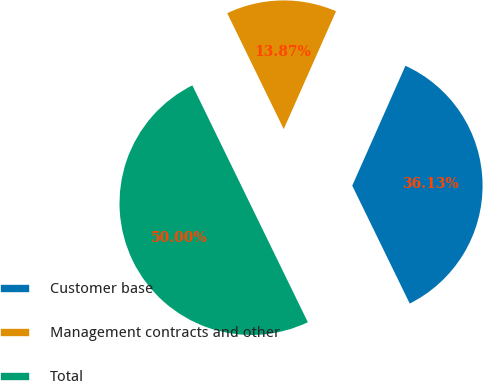<chart> <loc_0><loc_0><loc_500><loc_500><pie_chart><fcel>Customer base<fcel>Management contracts and other<fcel>Total<nl><fcel>36.13%<fcel>13.87%<fcel>50.0%<nl></chart> 